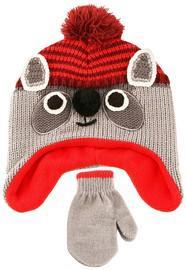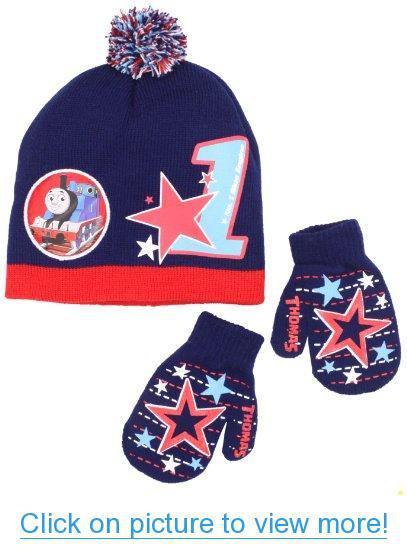The first image is the image on the left, the second image is the image on the right. Examine the images to the left and right. Is the description "One hat has an animal face on it." accurate? Answer yes or no. Yes. The first image is the image on the left, the second image is the image on the right. Assess this claim about the two images: "Exactly two knit hats are multicolor with a ribbed bottom and a pompon on top, with a set of matching mittens shown below the hat.". Correct or not? Answer yes or no. No. 